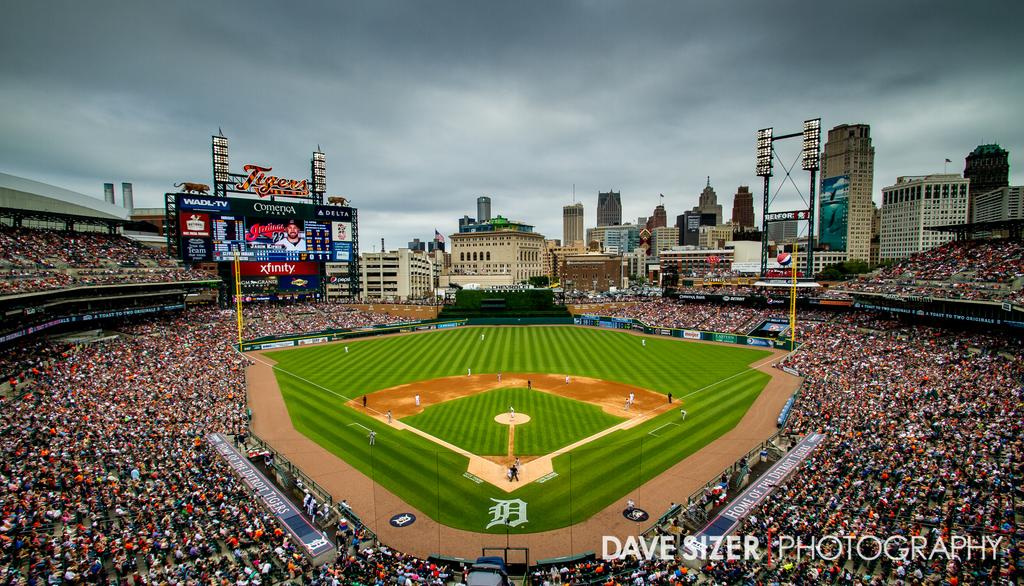Provide a one-sentence caption for the provided image. Baseball Stadium that is shown by Dave Sizer Photography. 